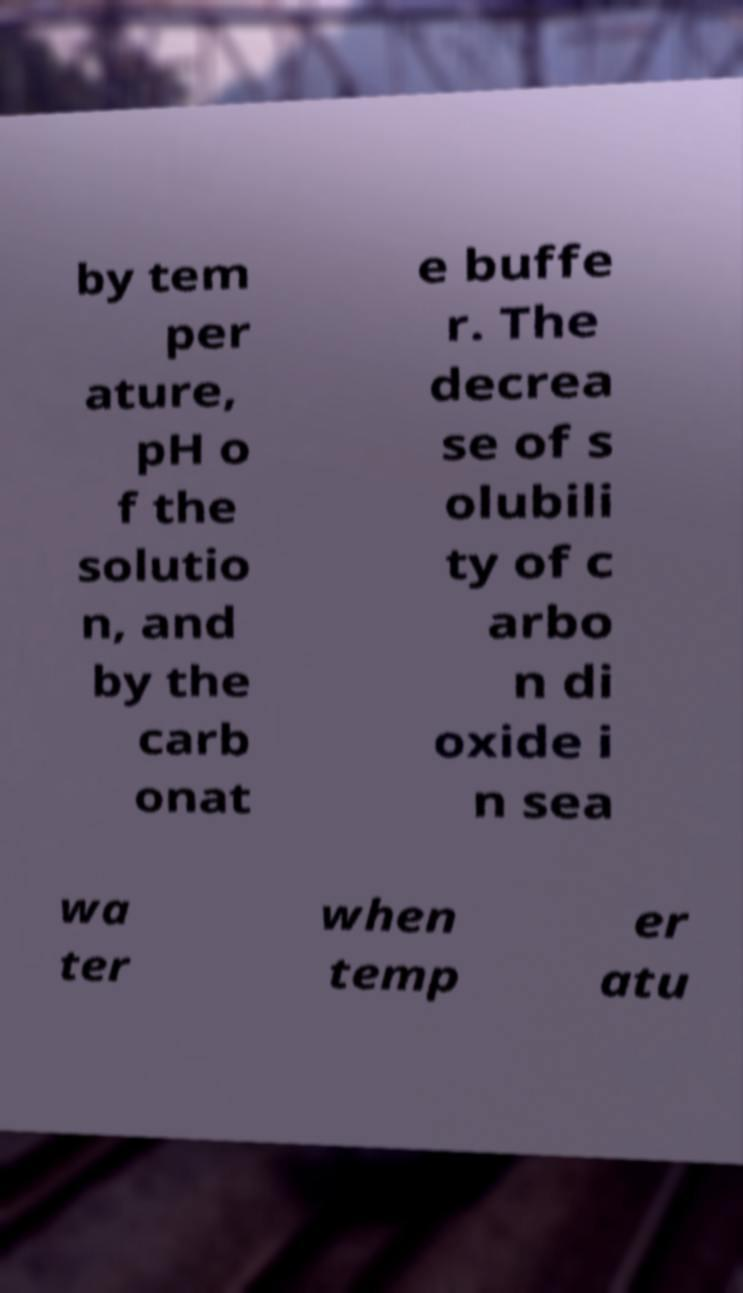What messages or text are displayed in this image? I need them in a readable, typed format. by tem per ature, pH o f the solutio n, and by the carb onat e buffe r. The decrea se of s olubili ty of c arbo n di oxide i n sea wa ter when temp er atu 